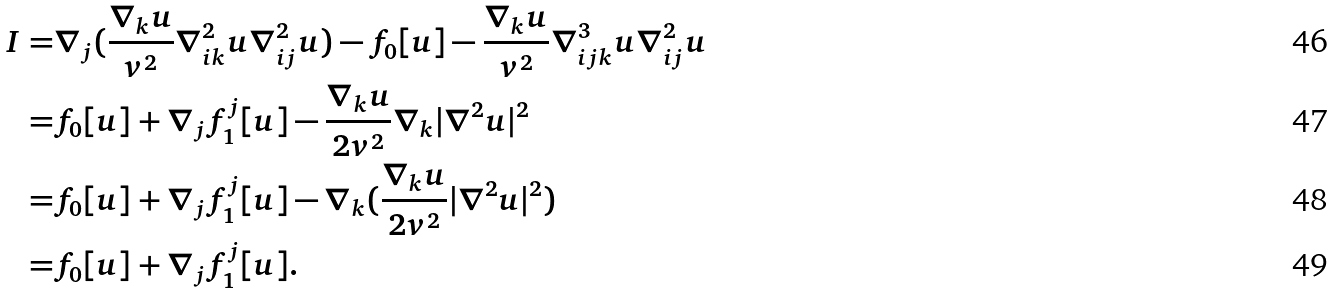Convert formula to latex. <formula><loc_0><loc_0><loc_500><loc_500>I = & \nabla _ { j } ( \frac { \nabla _ { k } u } { v ^ { 2 } } \nabla ^ { 2 } _ { i k } u \nabla ^ { 2 } _ { i j } u ) - f _ { 0 } [ u ] - \frac { \nabla _ { k } u } { v ^ { 2 } } \nabla ^ { 3 } _ { i j k } u \nabla ^ { 2 } _ { i j } u \\ = & f _ { 0 } [ u ] + \nabla _ { j } f _ { 1 } ^ { j } [ u ] - \frac { \nabla _ { k } u } { 2 v ^ { 2 } } \nabla _ { k } | \nabla ^ { 2 } u | ^ { 2 } \\ = & f _ { 0 } [ u ] + \nabla _ { j } f _ { 1 } ^ { j } [ u ] - \nabla _ { k } ( \frac { \nabla _ { k } u } { 2 v ^ { 2 } } | \nabla ^ { 2 } u | ^ { 2 } ) \\ = & f _ { 0 } [ u ] + \nabla _ { j } f _ { 1 } ^ { j } [ u ] .</formula> 